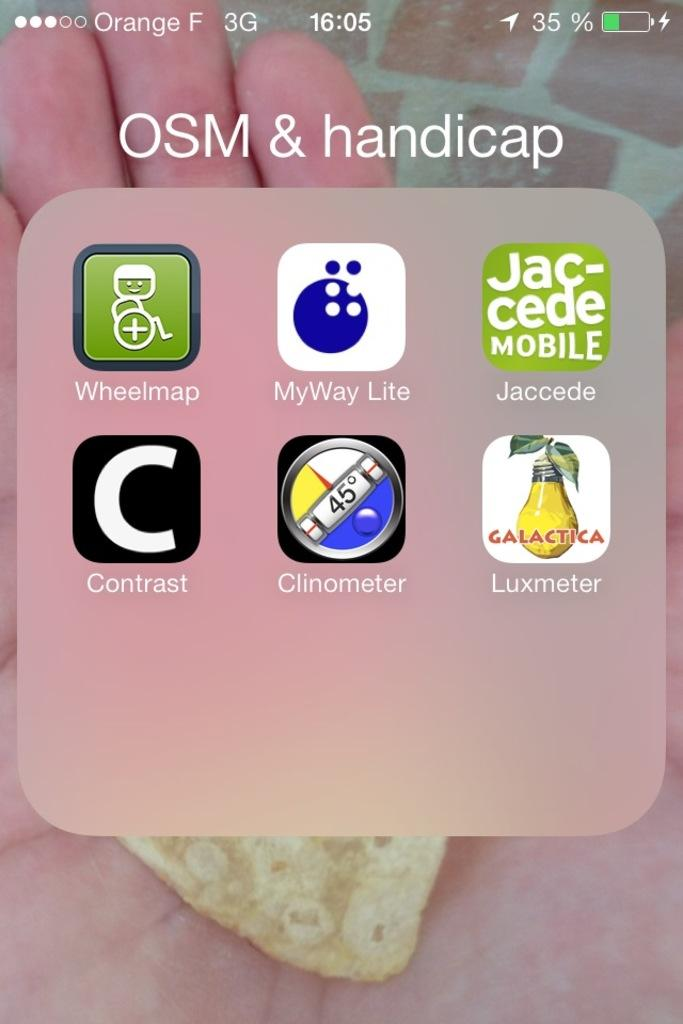<image>
Give a short and clear explanation of the subsequent image. A folder in a smart phone labeled OSM & handicap 